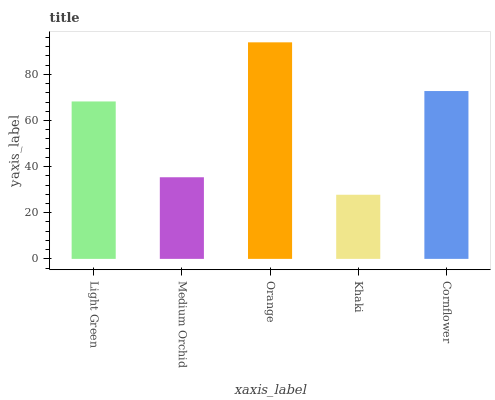Is Khaki the minimum?
Answer yes or no. Yes. Is Orange the maximum?
Answer yes or no. Yes. Is Medium Orchid the minimum?
Answer yes or no. No. Is Medium Orchid the maximum?
Answer yes or no. No. Is Light Green greater than Medium Orchid?
Answer yes or no. Yes. Is Medium Orchid less than Light Green?
Answer yes or no. Yes. Is Medium Orchid greater than Light Green?
Answer yes or no. No. Is Light Green less than Medium Orchid?
Answer yes or no. No. Is Light Green the high median?
Answer yes or no. Yes. Is Light Green the low median?
Answer yes or no. Yes. Is Cornflower the high median?
Answer yes or no. No. Is Cornflower the low median?
Answer yes or no. No. 